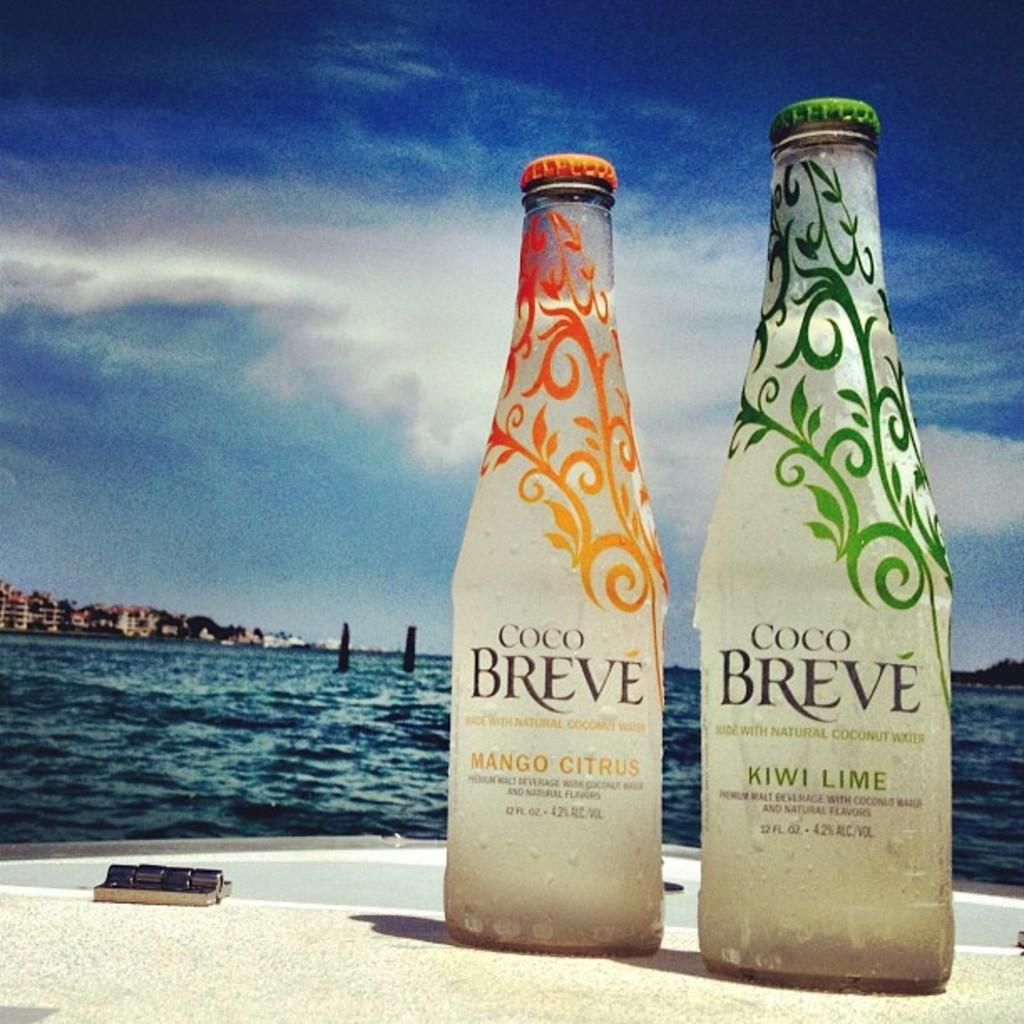<image>
Present a compact description of the photo's key features. Two bottles of Coco Breve on a boat in the water. 